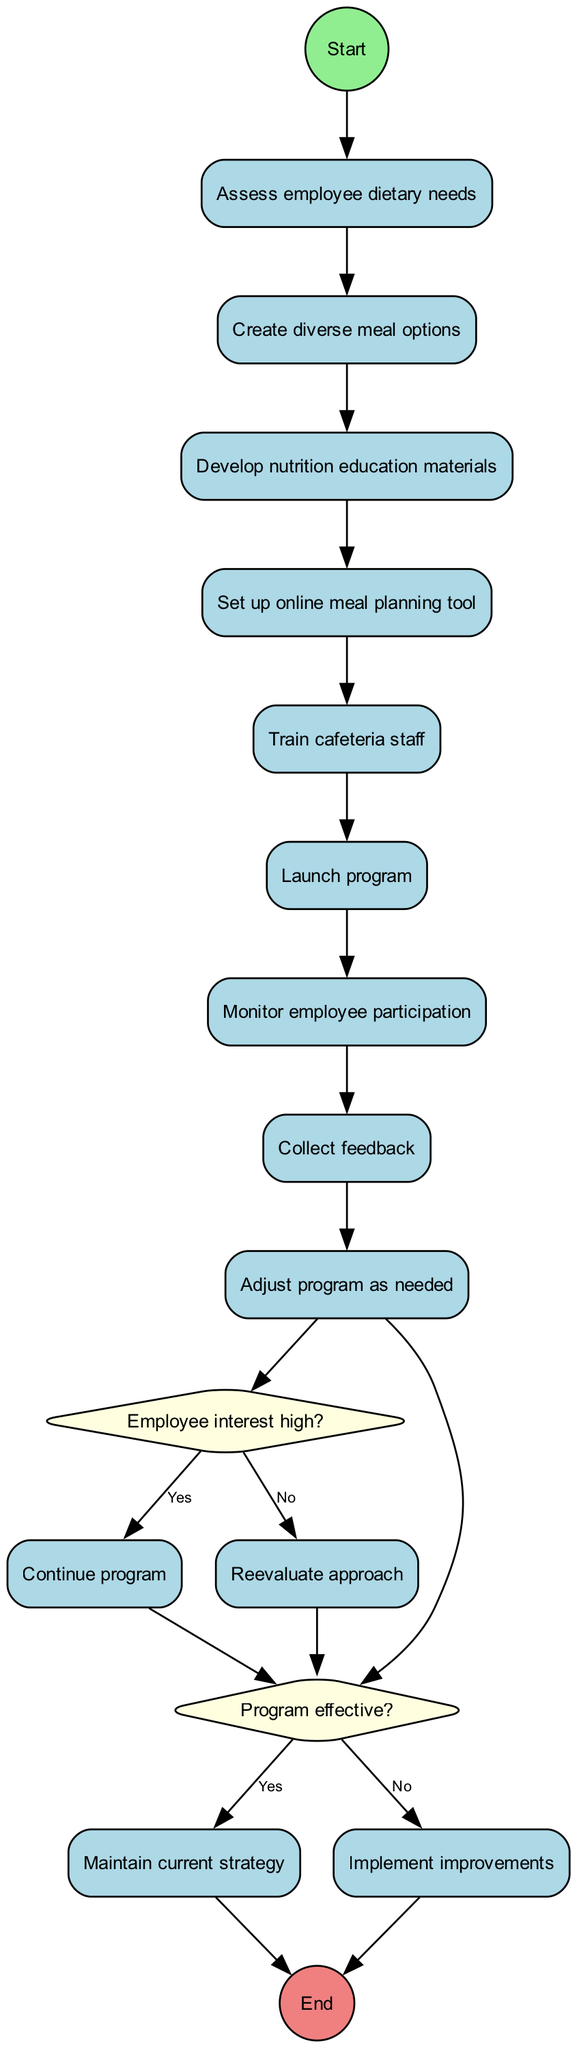What is the first activity in the diagram? The first activity listed is "Assess employee dietary needs." It is directly connected to the initial node "Start," indicating it is the first step in the process.
Answer: Assess employee dietary needs How many activities are present in the diagram? There are nine activities outlined in the diagram. These include all steps from assessing needs to adjusting the program.
Answer: Nine What decision follows the last activity? The decision that follows the last activity, "Launch program," is "Employee interest high?" This decision determines the continuation or reevaluation of the program.
Answer: Employee interest high? What is the outcome if the program is effective? If the program is determined to be effective, the outcome is to "Maintain current strategy," which implies no changes will be made to the existing plan.
Answer: Maintain current strategy Which activity is directly linked to the initial node? "Assess employee dietary needs" is the activity directly connected to the initial node "Start," indicating it is the first action taken in the process.
Answer: Assess employee dietary needs If employee interest is low, what action is taken? If employee interest is low, the action taken is to "Reevaluate approach," suggesting a need to change strategies to increase engagement.
Answer: Reevaluate approach What follows the decision node about employee interest? Following the decision node about employee interest, if "Yes," it continues the program, while if "No," it leads to reevaluating the approach.
Answer: Continue program or Reevaluate approach What is the last node in the diagram? The last node in the diagram is "End," indicating the completion of the process flow outlined in the activity diagram.
Answer: End 